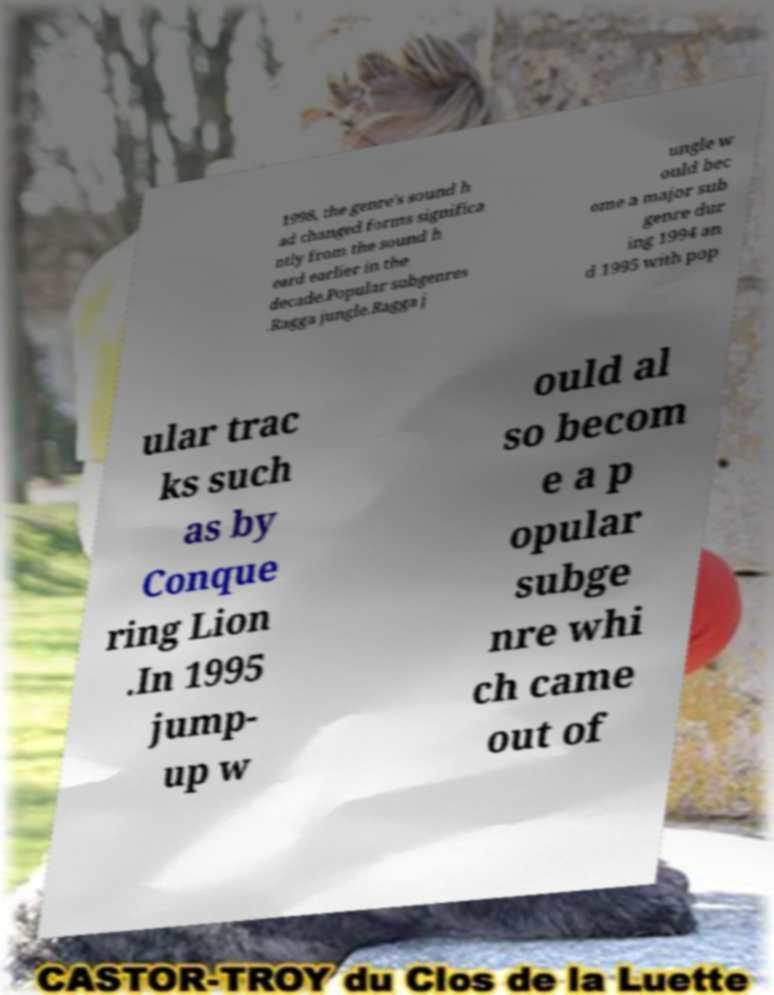I need the written content from this picture converted into text. Can you do that? 1998, the genre's sound h ad changed forms significa ntly from the sound h eard earlier in the decade.Popular subgenres .Ragga jungle.Ragga j ungle w ould bec ome a major sub genre dur ing 1994 an d 1995 with pop ular trac ks such as by Conque ring Lion .In 1995 jump- up w ould al so becom e a p opular subge nre whi ch came out of 